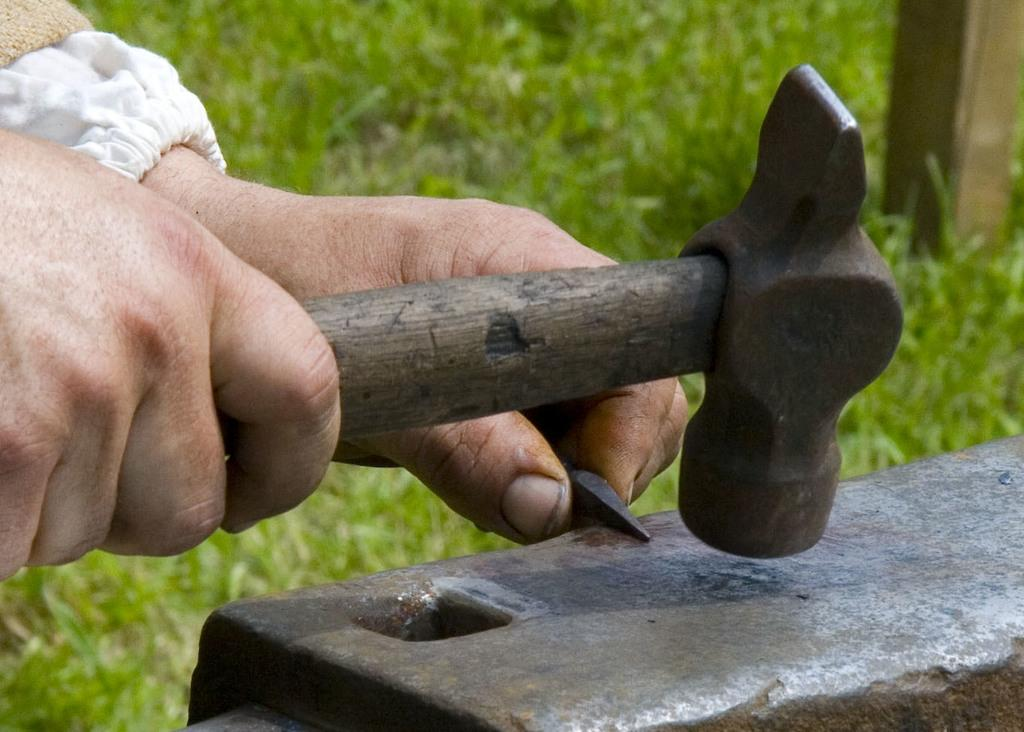What object can be seen in the image? There is a hammer in the image. Whose hand is visible in the image? There is a person's hand in the image. What type of natural environment is shown in the image? There is grass visible in the image. What flavor of pocket can be seen in the image? There is no pocket or flavor present in the image. 